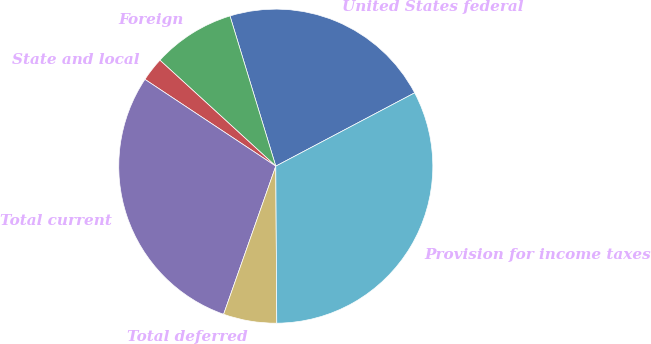Convert chart. <chart><loc_0><loc_0><loc_500><loc_500><pie_chart><fcel>United States federal<fcel>Foreign<fcel>State and local<fcel>Total current<fcel>Total deferred<fcel>Provision for income taxes<nl><fcel>21.98%<fcel>8.5%<fcel>2.47%<fcel>28.93%<fcel>5.49%<fcel>32.63%<nl></chart> 